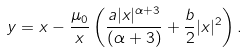<formula> <loc_0><loc_0><loc_500><loc_500>y = x - \frac { \mu _ { 0 } } { x } \left ( \frac { a | x | ^ { \alpha + 3 } } { ( \alpha + 3 ) } + \frac { b } { 2 } | x | ^ { 2 } \right ) .</formula> 